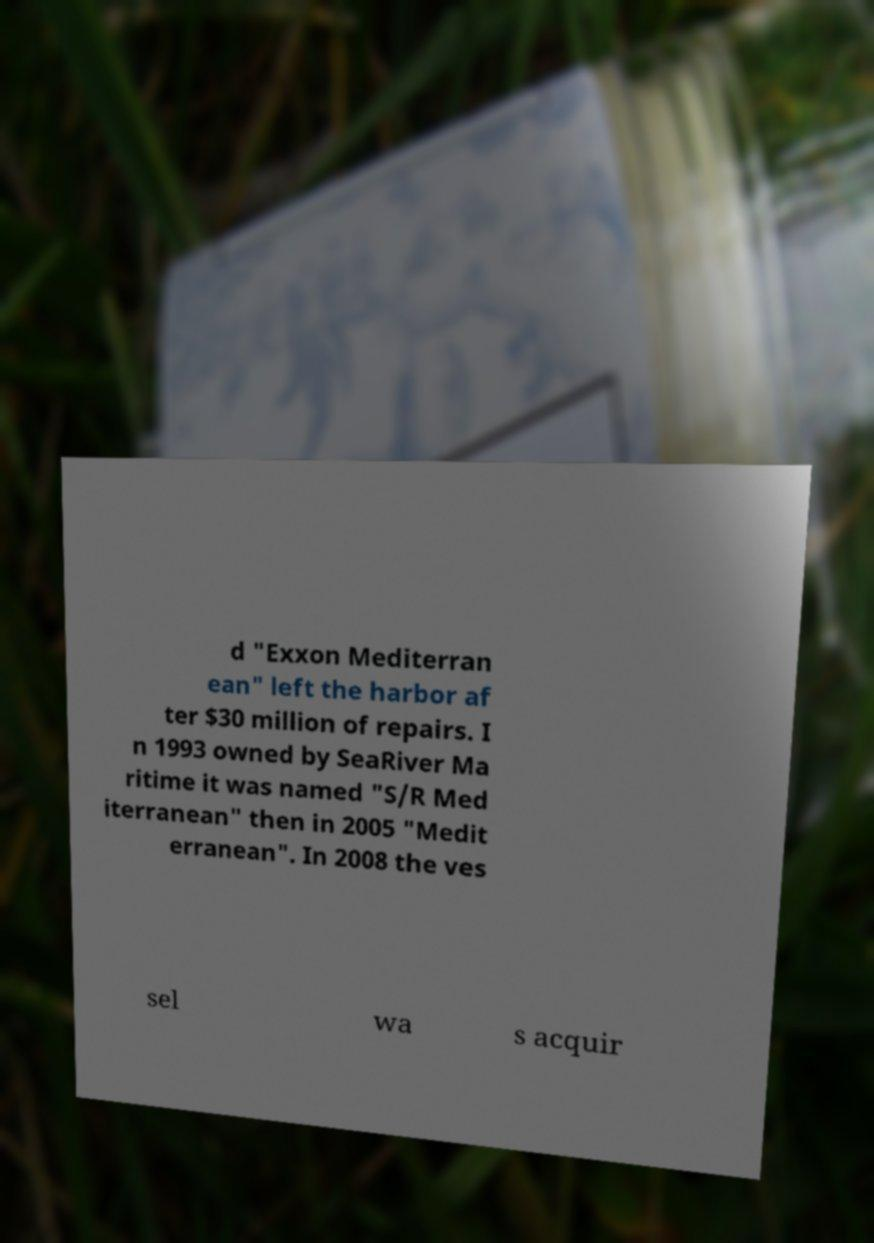There's text embedded in this image that I need extracted. Can you transcribe it verbatim? d "Exxon Mediterran ean" left the harbor af ter $30 million of repairs. I n 1993 owned by SeaRiver Ma ritime it was named "S/R Med iterranean" then in 2005 "Medit erranean". In 2008 the ves sel wa s acquir 